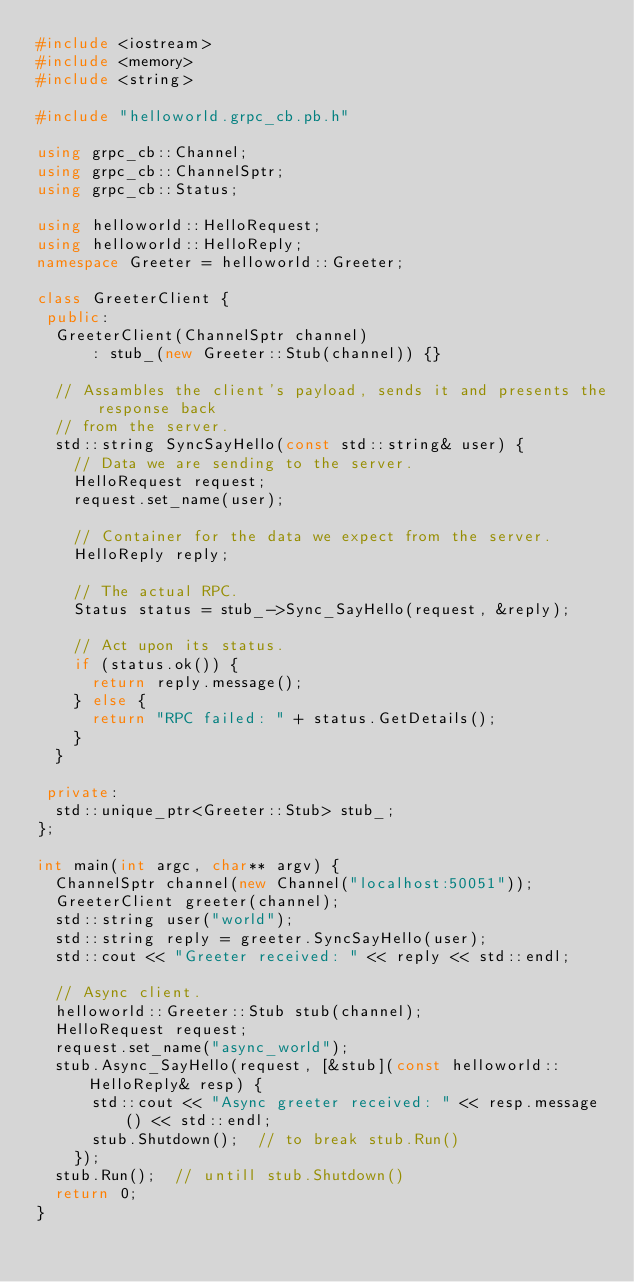Convert code to text. <code><loc_0><loc_0><loc_500><loc_500><_C++_>#include <iostream>
#include <memory>
#include <string>

#include "helloworld.grpc_cb.pb.h"

using grpc_cb::Channel;
using grpc_cb::ChannelSptr;
using grpc_cb::Status;

using helloworld::HelloRequest;
using helloworld::HelloReply;
namespace Greeter = helloworld::Greeter;

class GreeterClient {
 public:
  GreeterClient(ChannelSptr channel)
      : stub_(new Greeter::Stub(channel)) {}

  // Assambles the client's payload, sends it and presents the response back
  // from the server.
  std::string SyncSayHello(const std::string& user) {
    // Data we are sending to the server.
    HelloRequest request;
    request.set_name(user);

    // Container for the data we expect from the server.
    HelloReply reply;

    // The actual RPC.
    Status status = stub_->Sync_SayHello(request, &reply);

    // Act upon its status.
    if (status.ok()) {
      return reply.message();
    } else {
      return "RPC failed: " + status.GetDetails();
    }
  }

 private:
  std::unique_ptr<Greeter::Stub> stub_;
};

int main(int argc, char** argv) {
  ChannelSptr channel(new Channel("localhost:50051"));
  GreeterClient greeter(channel);
  std::string user("world");
  std::string reply = greeter.SyncSayHello(user);
  std::cout << "Greeter received: " << reply << std::endl;

  // Async client.
  helloworld::Greeter::Stub stub(channel);
  HelloRequest request;
  request.set_name("async_world");
  stub.Async_SayHello(request, [&stub](const helloworld::HelloReply& resp) {
      std::cout << "Async greeter received: " << resp.message() << std::endl;
      stub.Shutdown();  // to break stub.Run()
    });
  stub.Run();  // untill stub.Shutdown()
  return 0;
}
</code> 